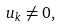<formula> <loc_0><loc_0><loc_500><loc_500>u _ { k } \not = 0 ,</formula> 